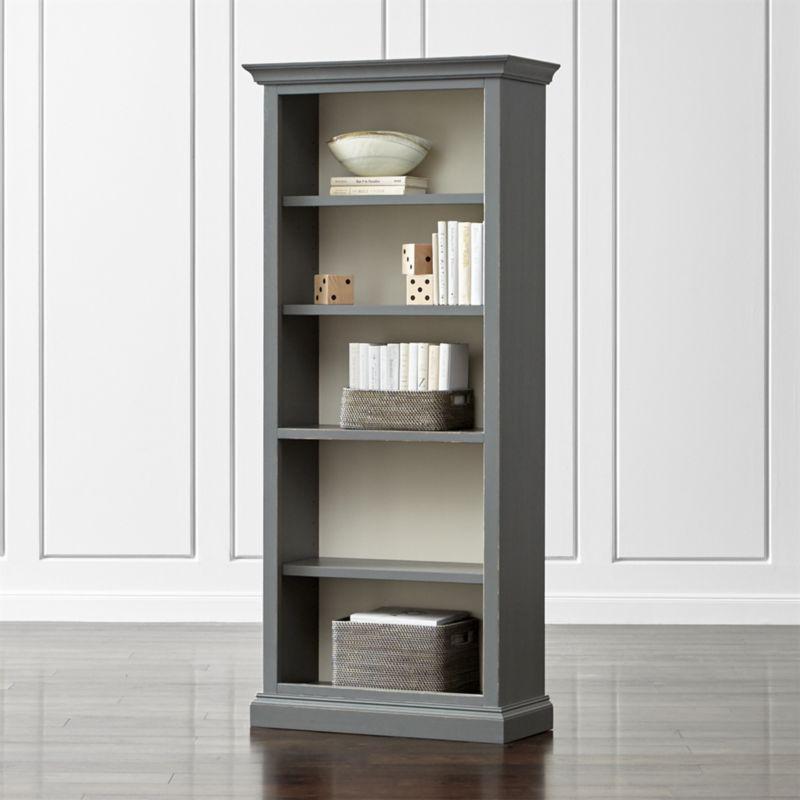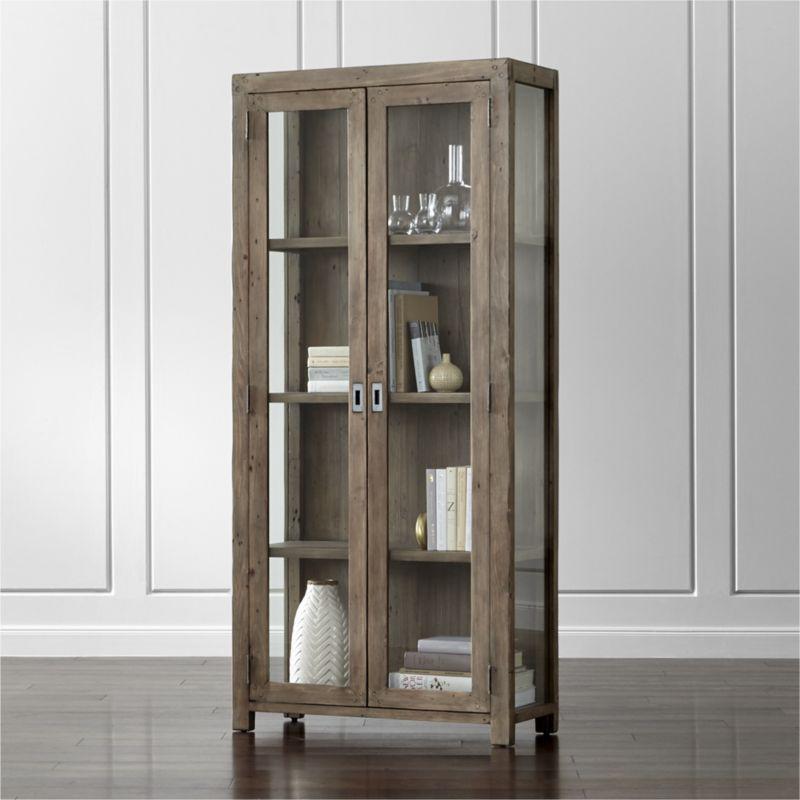The first image is the image on the left, the second image is the image on the right. Assess this claim about the two images: "At least one bookcase has open shelves, no backboard to it.". Correct or not? Answer yes or no. No. 